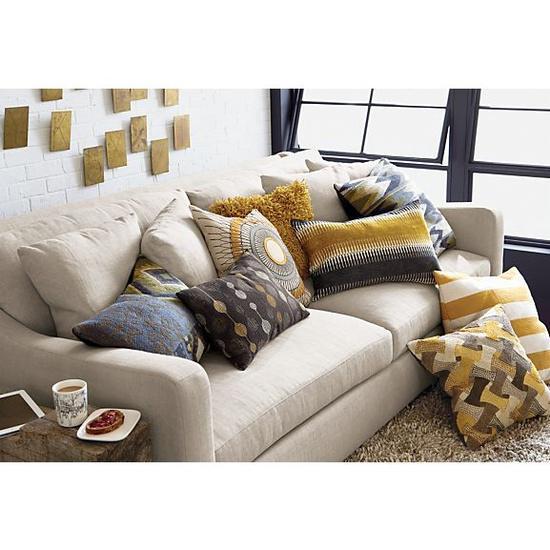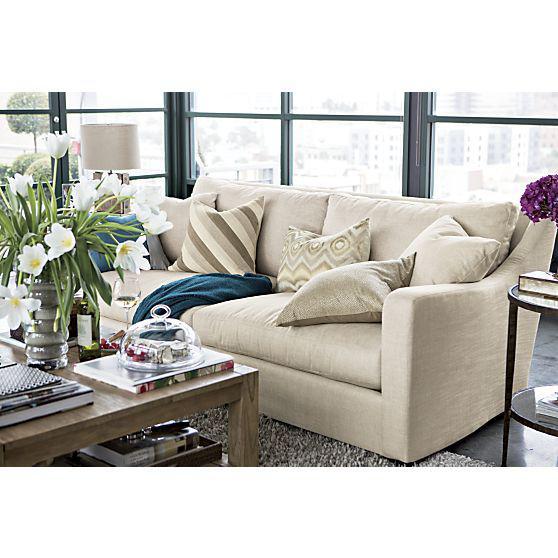The first image is the image on the left, the second image is the image on the right. For the images shown, is this caption "There is a plant on the coffee table in at least one image." true? Answer yes or no. Yes. 